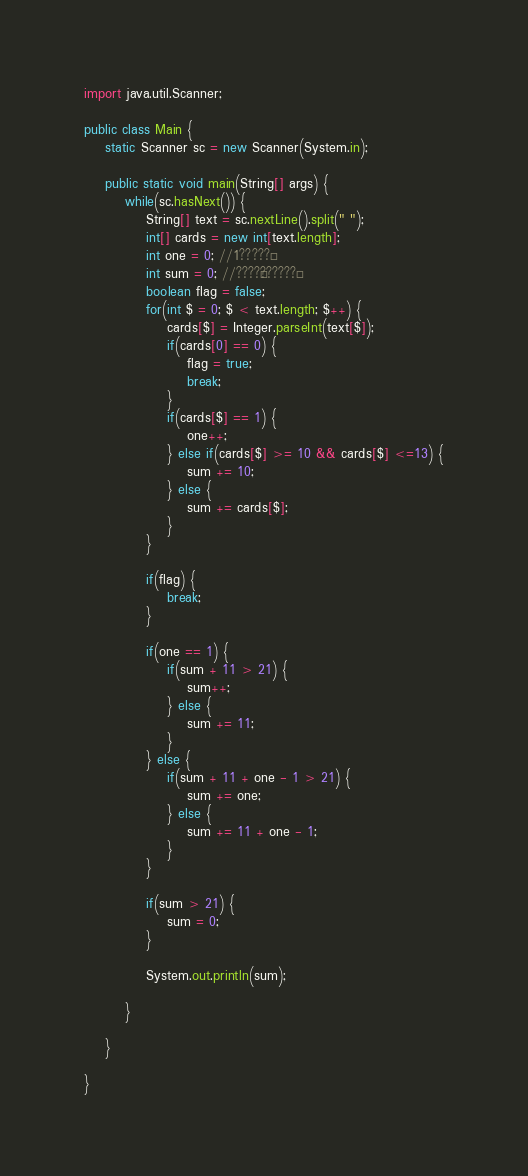<code> <loc_0><loc_0><loc_500><loc_500><_Java_>import java.util.Scanner;

public class Main {
	static Scanner sc = new Scanner(System.in);

	public static void main(String[] args) {
		while(sc.hasNext()) {
			String[] text = sc.nextLine().split(" ");
			int[] cards = new int[text.length];
			int one = 0; //1?????°
			int sum = 0; //????¨??????°
			boolean flag = false;
			for(int $ = 0; $ < text.length; $++) {
				cards[$] = Integer.parseInt(text[$]);
				if(cards[0] == 0) {
					flag = true;
					break;
				}
				if(cards[$] == 1) {
					one++;
				} else if(cards[$] >= 10 && cards[$] <=13) {
					sum += 10;
				} else {
					sum += cards[$];
				}
			}

			if(flag) {
				break;
			}

			if(one == 1) {
				if(sum + 11 > 21) {
					sum++;
				} else {
					sum += 11;
				}
			} else {
				if(sum + 11 + one - 1 > 21) {
					sum += one;
				} else {
					sum += 11 + one - 1;
				}
			}

			if(sum > 21) {
				sum = 0;
			}

			System.out.println(sum);

		}

	}

}</code> 